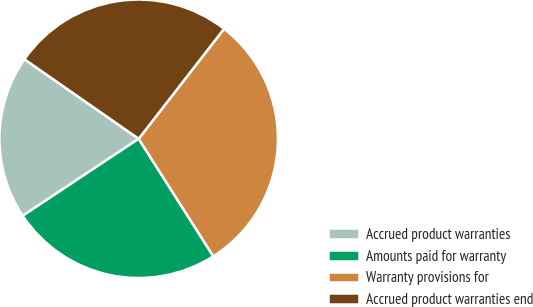Convert chart to OTSL. <chart><loc_0><loc_0><loc_500><loc_500><pie_chart><fcel>Accrued product warranties<fcel>Amounts paid for warranty<fcel>Warranty provisions for<fcel>Accrued product warranties end<nl><fcel>19.01%<fcel>24.68%<fcel>30.49%<fcel>25.83%<nl></chart> 